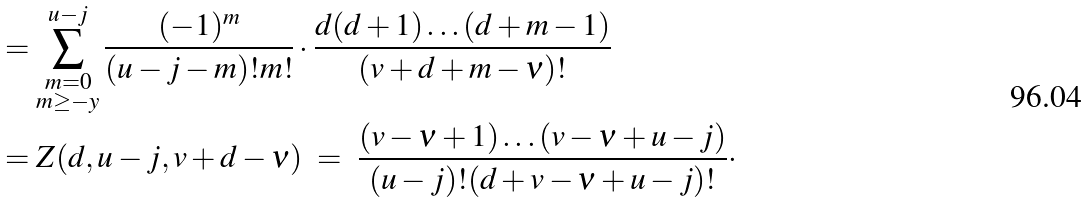Convert formula to latex. <formula><loc_0><loc_0><loc_500><loc_500>& = \sum ^ { u - j } _ { \substack { m = 0 \\ m \geq - y } } \frac { ( - 1 ) ^ { m } } { ( u - j - m ) ! m ! } \cdot \frac { d ( d + 1 ) \dots ( d + m - 1 ) } { ( v + d + m - \nu ) ! } \\ & = Z ( d , u - j , v + d - \nu ) \ = \ \frac { ( v - \nu + 1 ) \dots ( v - \nu + u - j ) } { ( u - j ) ! ( d + v - \nu + u - j ) ! } \cdot</formula> 